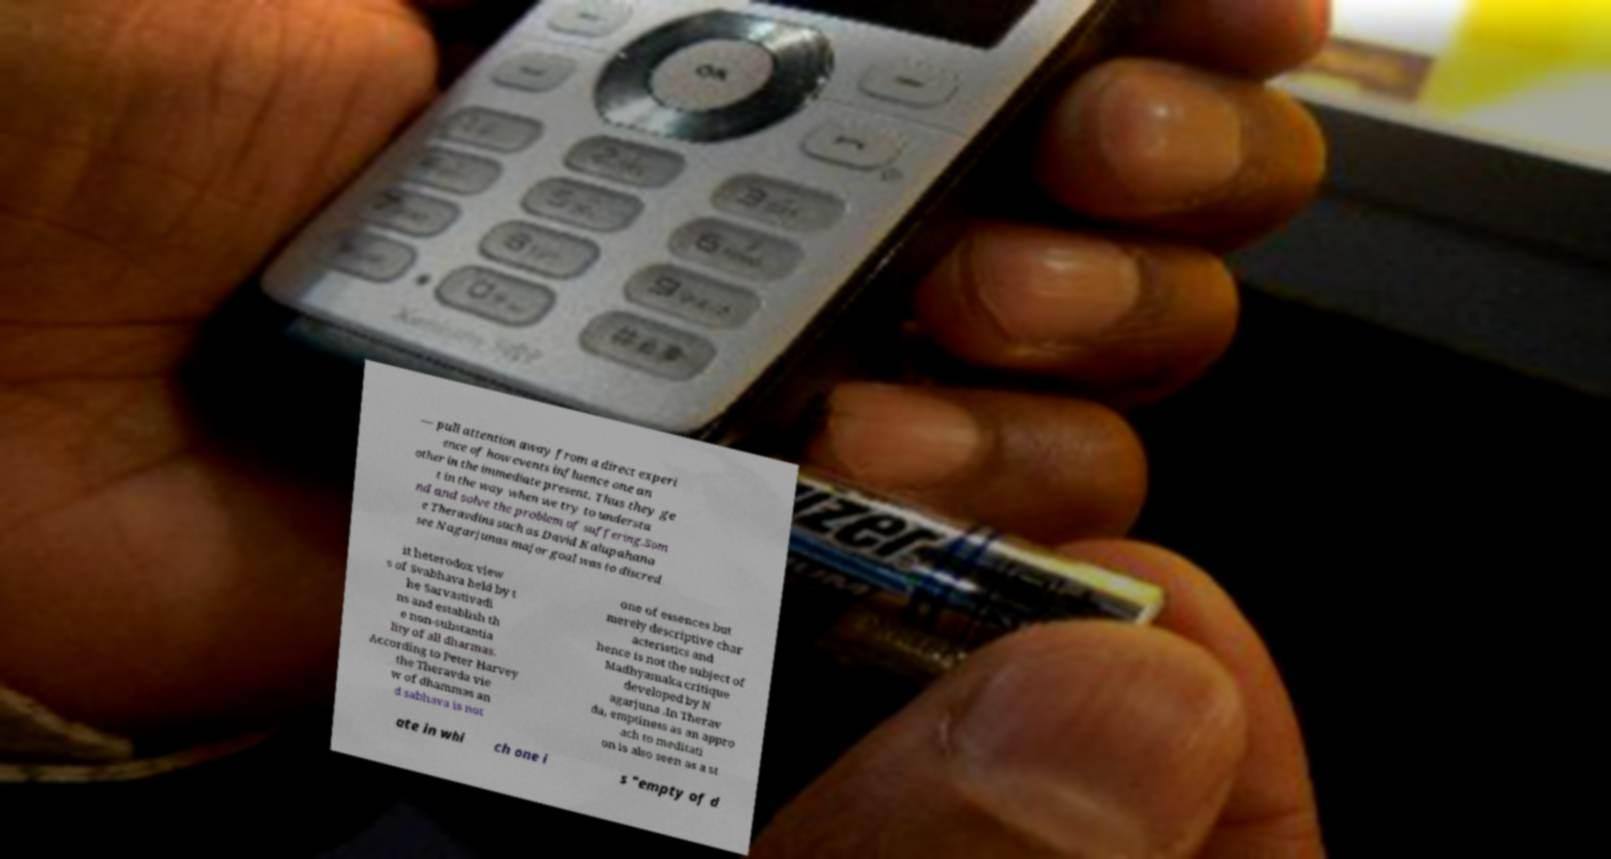Please identify and transcribe the text found in this image. — pull attention away from a direct experi ence of how events influence one an other in the immediate present. Thus they ge t in the way when we try to understa nd and solve the problem of suffering.Som e Theravdins such as David Kalupahana see Nagarjunas major goal was to discred it heterodox view s of Svabhava held by t he Sarvastivadi ns and establish th e non-substantia lity of all dharmas. According to Peter Harvey the Theravda vie w of dhammas an d sabhava is not one of essences but merely descriptive char acteristics and hence is not the subject of Madhyamaka critique developed by N agarjuna .In Therav da, emptiness as an appro ach to meditati on is also seen as a st ate in whi ch one i s "empty of d 